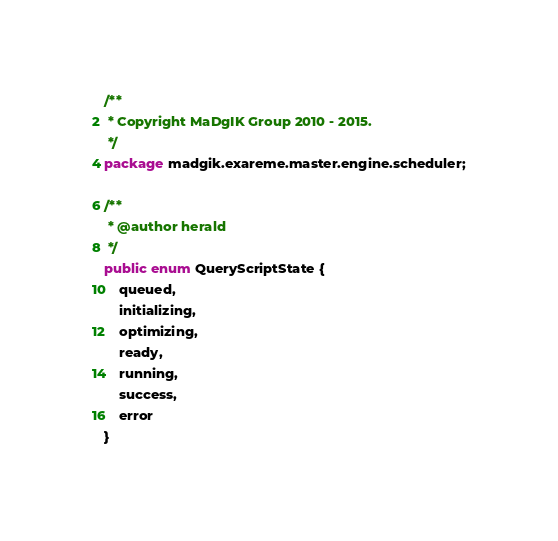<code> <loc_0><loc_0><loc_500><loc_500><_Java_>/**
 * Copyright MaDgIK Group 2010 - 2015.
 */
package madgik.exareme.master.engine.scheduler;

/**
 * @author herald
 */
public enum QueryScriptState {
    queued,
    initializing,
    optimizing,
    ready,
    running,
    success,
    error
}
</code> 